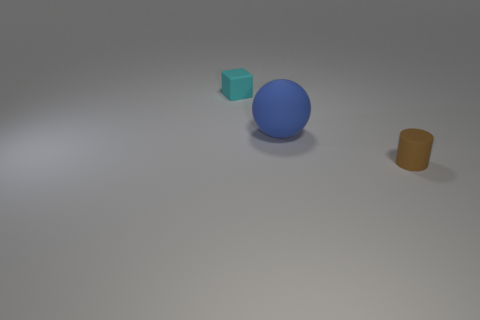There is a small matte thing on the right side of the rubber thing to the left of the rubber sphere; what number of brown objects are behind it?
Your answer should be very brief. 0. How many small brown cylinders are there?
Give a very brief answer. 1. Is the number of brown rubber cylinders that are behind the rubber sphere less than the number of brown cylinders in front of the brown cylinder?
Keep it short and to the point. No. Are there fewer brown objects that are behind the cyan rubber block than big gray rubber balls?
Provide a short and direct response. No. What material is the small thing that is to the right of the small rubber thing that is left of the tiny object that is to the right of the tiny cyan cube?
Provide a short and direct response. Rubber. What number of things are rubber objects on the left side of the small brown thing or big rubber spheres that are right of the small cyan matte block?
Ensure brevity in your answer.  2. Are there the same number of big blue rubber spheres and small yellow metal spheres?
Your response must be concise. No. How many rubber objects are large gray blocks or brown cylinders?
Give a very brief answer. 1. There is a small cyan thing that is made of the same material as the ball; what is its shape?
Keep it short and to the point. Cube. What number of brown things are the same shape as the tiny cyan matte thing?
Provide a short and direct response. 0. 